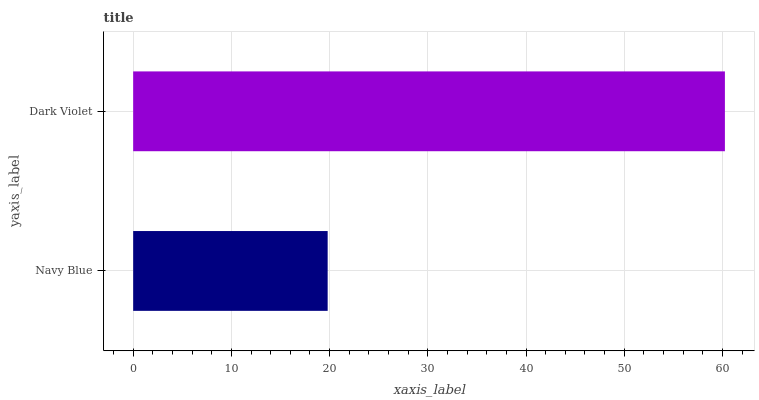Is Navy Blue the minimum?
Answer yes or no. Yes. Is Dark Violet the maximum?
Answer yes or no. Yes. Is Dark Violet the minimum?
Answer yes or no. No. Is Dark Violet greater than Navy Blue?
Answer yes or no. Yes. Is Navy Blue less than Dark Violet?
Answer yes or no. Yes. Is Navy Blue greater than Dark Violet?
Answer yes or no. No. Is Dark Violet less than Navy Blue?
Answer yes or no. No. Is Dark Violet the high median?
Answer yes or no. Yes. Is Navy Blue the low median?
Answer yes or no. Yes. Is Navy Blue the high median?
Answer yes or no. No. Is Dark Violet the low median?
Answer yes or no. No. 